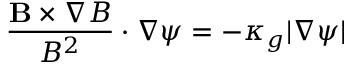Convert formula to latex. <formula><loc_0><loc_0><loc_500><loc_500>\frac { B \times \nabla B } { B ^ { 2 } } \cdot \nabla \psi = - \kappa _ { g } | \nabla \psi |</formula> 